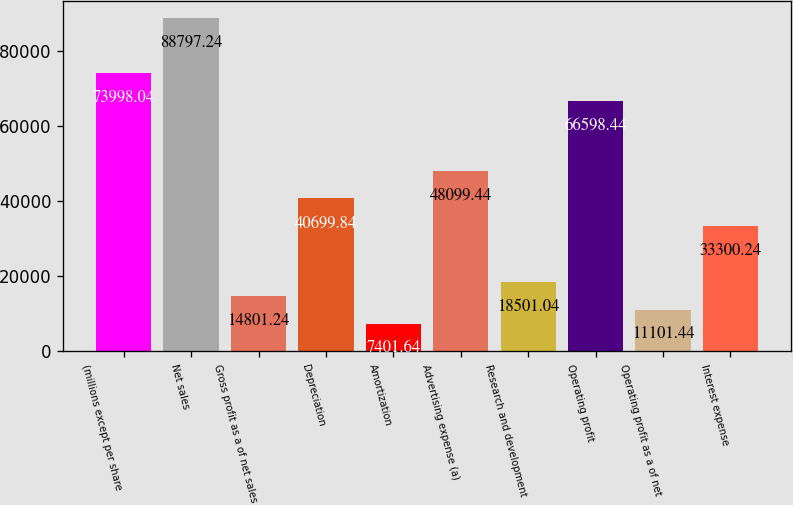<chart> <loc_0><loc_0><loc_500><loc_500><bar_chart><fcel>(millions except per share<fcel>Net sales<fcel>Gross profit as a of net sales<fcel>Depreciation<fcel>Amortization<fcel>Advertising expense (a)<fcel>Research and development<fcel>Operating profit<fcel>Operating profit as a of net<fcel>Interest expense<nl><fcel>73998<fcel>88797.2<fcel>14801.2<fcel>40699.8<fcel>7401.64<fcel>48099.4<fcel>18501<fcel>66598.4<fcel>11101.4<fcel>33300.2<nl></chart> 